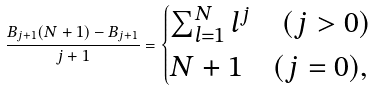<formula> <loc_0><loc_0><loc_500><loc_500>\frac { B _ { j + 1 } ( N + 1 ) - B _ { j + 1 } } { j + 1 } = \begin{cases} \sum _ { l = 1 } ^ { N } l ^ { j } \quad ( j > 0 ) \\ N + 1 \quad ( j = 0 ) , \end{cases}</formula> 